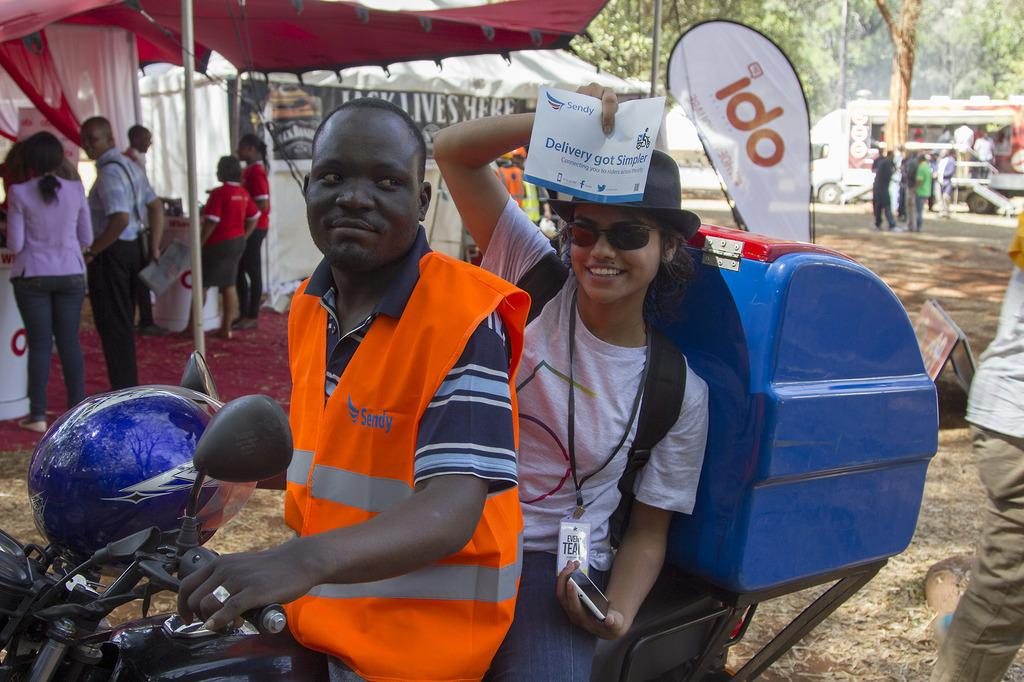What is the main subject of the image? The main subject of the image is a guy riding a bike. Who is accompanying the guy on the bike? There is a lady sitting behind the guy on the bike. What can be seen in the background of the image? In the background, there are many people in stalls. Can you tell me how many zippers are visible on the bike in the image? There is no mention of zippers in the image, so it is not possible to determine how many are visible. 